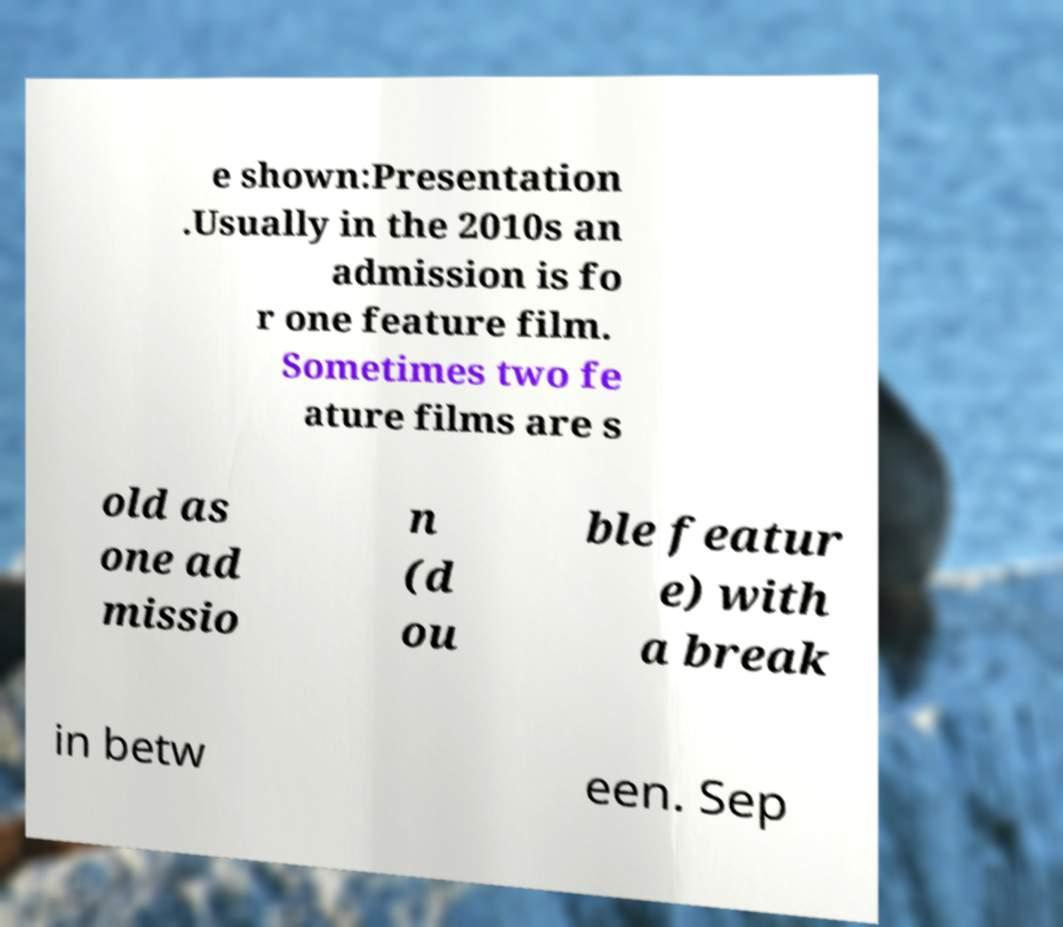Can you accurately transcribe the text from the provided image for me? e shown:Presentation .Usually in the 2010s an admission is fo r one feature film. Sometimes two fe ature films are s old as one ad missio n (d ou ble featur e) with a break in betw een. Sep 